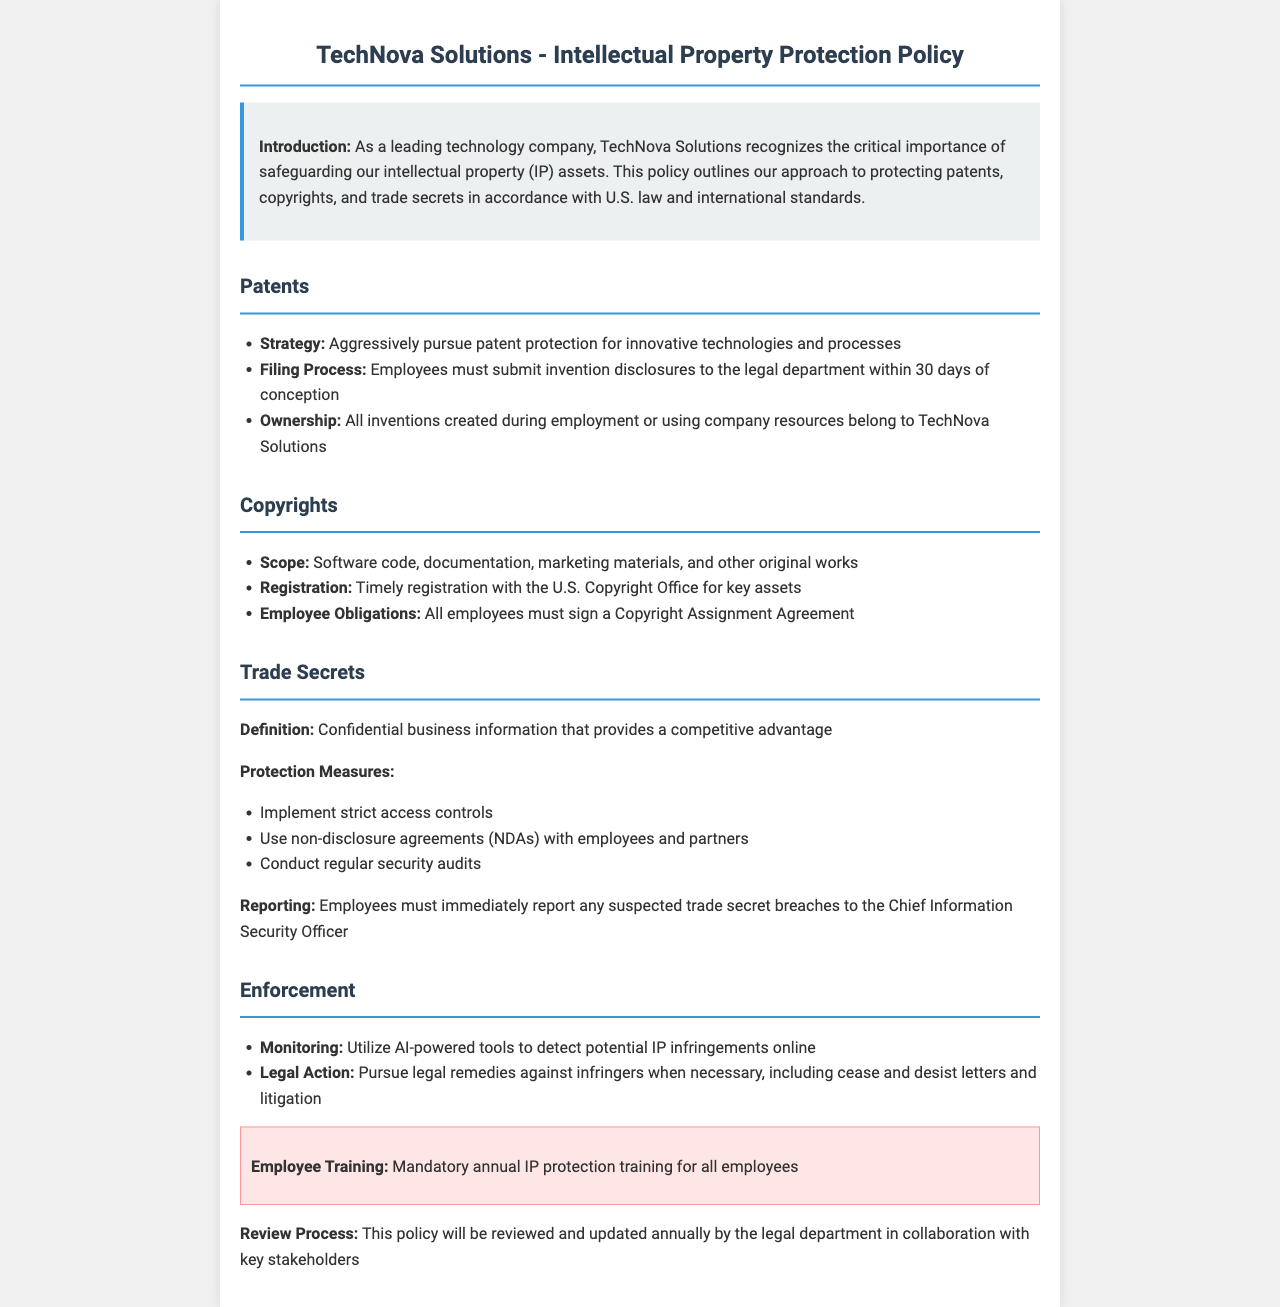What is the main purpose of the policy? The main purpose of the policy is to outline TechNova Solutions' approach to protecting intellectual property assets.
Answer: Safeguarding intellectual property assets What must employees do within 30 days of conception of an invention? Employees must submit invention disclosures to the legal department within 30 days of conception.
Answer: Submit invention disclosures What type of works are covered under copyrights? The document states that software code, documentation, marketing materials, and other original works are covered.
Answer: Software code, documentation, marketing materials What measure is taken to protect trade secrets? One of the measures taken to protect trade secrets is to implement strict access controls.
Answer: Implement strict access controls What is required of employees regarding trade secret breaches? Employees must immediately report any suspected trade secret breaches to the Chief Information Security Officer.
Answer: Report to Chief Information Security Officer How often must employees undergo IP protection training? The policy states that it is mandatory for employees to undergo training annually.
Answer: Annually What tools are utilized to monitor IP infringements? The document specifies that AI-powered tools are utilized to detect potential IP infringements online.
Answer: AI-powered tools What type of legal actions can be pursued against infringers? The document mentions pursuing legal remedies including cease and desist letters and litigation.
Answer: Cease and desist letters and litigation 